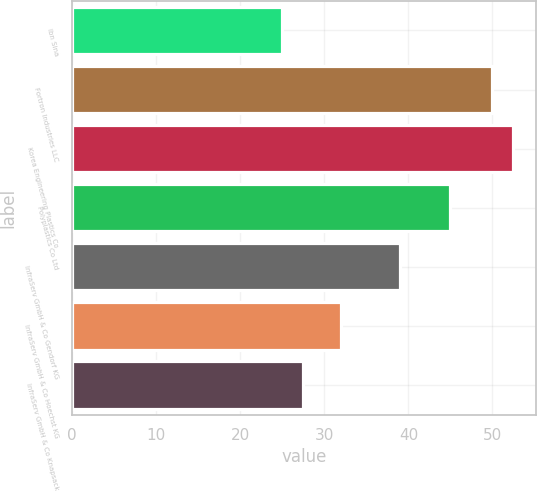<chart> <loc_0><loc_0><loc_500><loc_500><bar_chart><fcel>Ibn Sina<fcel>Fortron Industries LLC<fcel>Korea Engineering Plastics Co<fcel>Polyplastics Co Ltd<fcel>InfraServ GmbH & Co Gendorf KG<fcel>InfraServ GmbH & Co Hoechst KG<fcel>InfraServ GmbH & Co Knapsack<nl><fcel>25<fcel>50<fcel>52.5<fcel>45<fcel>39<fcel>32<fcel>27.5<nl></chart> 